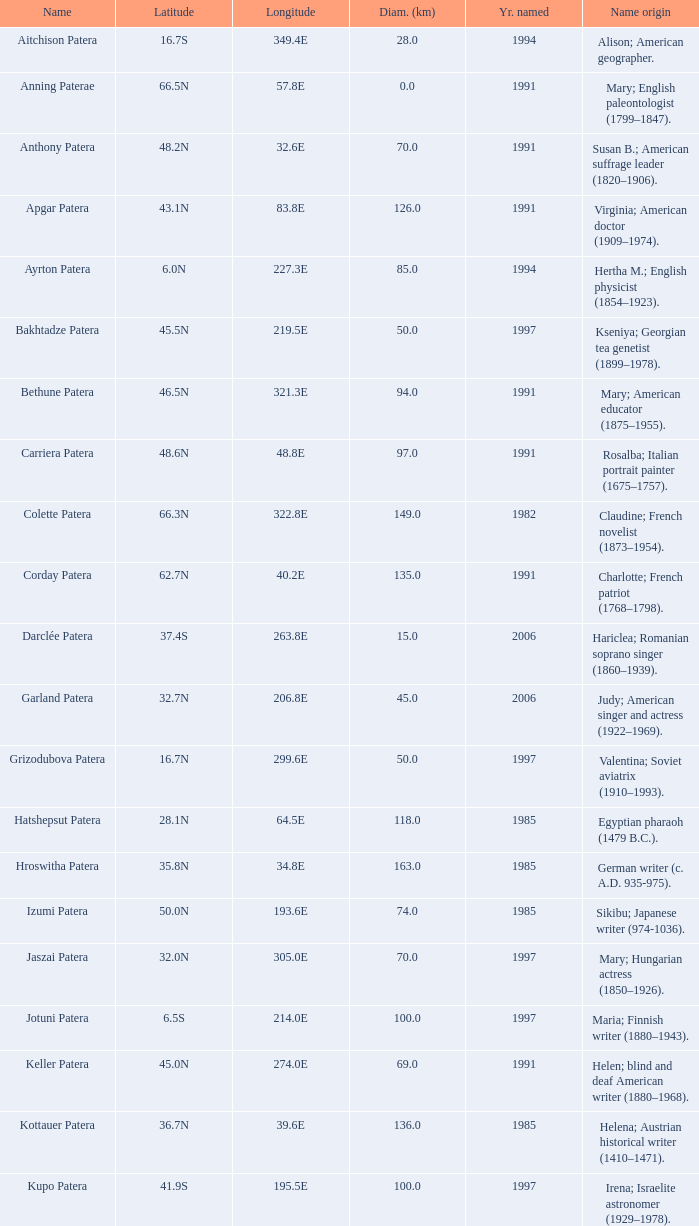What is  the diameter in km of the feature with a longitude of 40.2E?  135.0. 